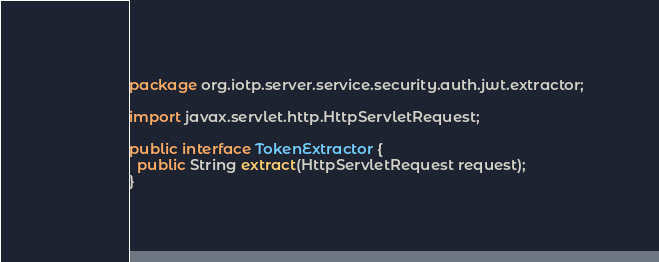<code> <loc_0><loc_0><loc_500><loc_500><_Java_>package org.iotp.server.service.security.auth.jwt.extractor;

import javax.servlet.http.HttpServletRequest;

public interface TokenExtractor {
  public String extract(HttpServletRequest request);
}</code> 